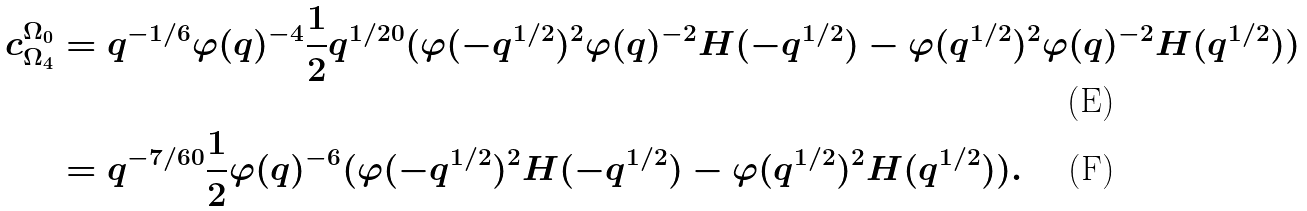Convert formula to latex. <formula><loc_0><loc_0><loc_500><loc_500>c _ { \Omega _ { 4 } } ^ { \Omega _ { 0 } } & = q ^ { - 1 / 6 } \varphi ( q ) ^ { - 4 } \frac { 1 } { 2 } q ^ { 1 / 2 0 } ( \varphi ( - q ^ { 1 / 2 } ) ^ { 2 } \varphi ( q ) ^ { - 2 } H ( - q ^ { 1 / 2 } ) - \varphi ( q ^ { 1 / 2 } ) ^ { 2 } \varphi ( q ) ^ { - 2 } H ( q ^ { 1 / 2 } ) ) \\ & = q ^ { - 7 / 6 0 } \frac { 1 } { 2 } \varphi ( q ) ^ { - 6 } ( \varphi ( - q ^ { 1 / 2 } ) ^ { 2 } H ( - q ^ { 1 / 2 } ) - \varphi ( q ^ { 1 / 2 } ) ^ { 2 } H ( q ^ { 1 / 2 } ) ) .</formula> 